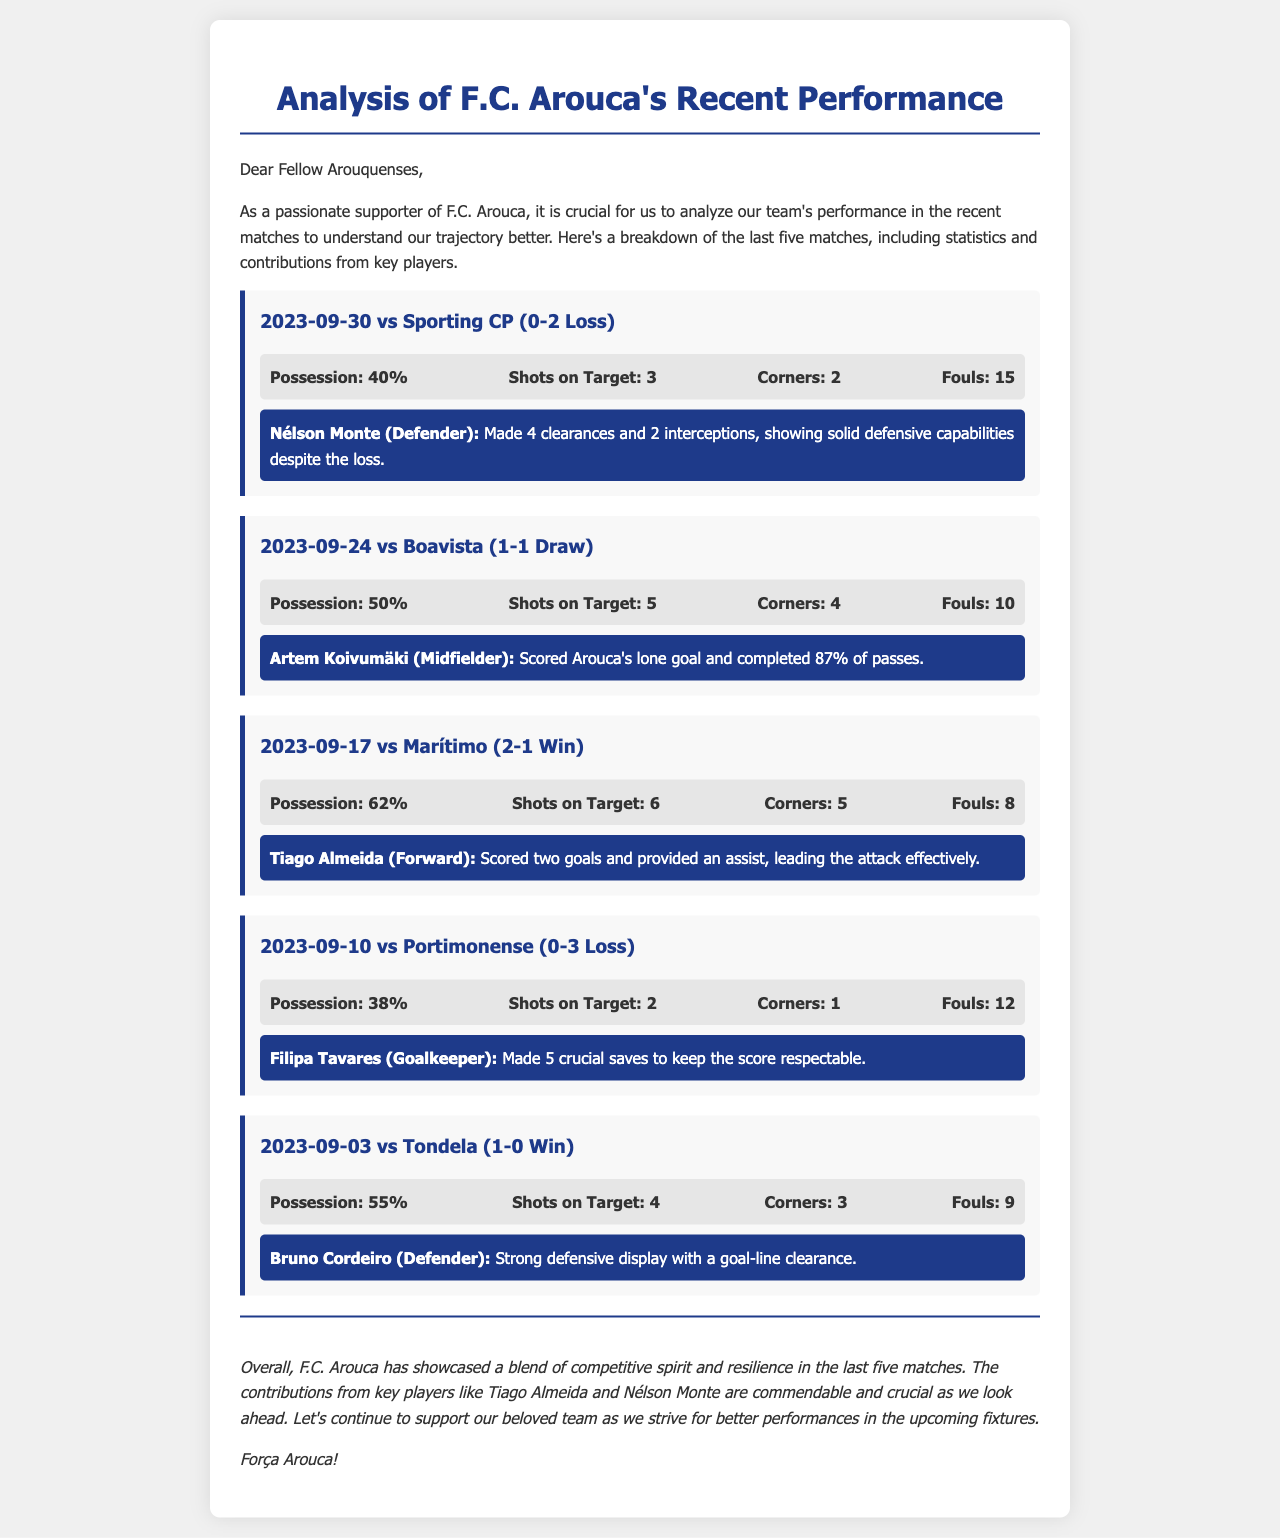What was F.C. Arouca's possession percentage against Sporting CP? The document states that F.C. Arouca had 40% possession in the match against Sporting CP.
Answer: 40% Who scored Arouca's lone goal in the match against Boavista? The document mentions that Artem Koivumäki scored Arouca's only goal in the match against Boavista.
Answer: Artem Koivumäki How many corners did F.C. Arouca have in the match against Marítimo? According to the document, F.C. Arouca had 5 corners in the match against Marítimo.
Answer: 5 What was the outcome of the match on 2023-09-03 against Tondela? The document indicates that F.C. Arouca won the match against Tondela.
Answer: Win Which player made 5 crucial saves against Portimonense? The document states that Filipa Tavares made 5 crucial saves during the match against Portimonense.
Answer: Filipa Tavares What is highlighted about Tiago Almeida's performance in the match against Marítimo? The document highlights that Tiago Almeida scored two goals and provided an assist in the match against Marítimo.
Answer: Scored two goals and provided an assist In how many matches did F.C. Arouca score goals in the last five games analyzed? The document notes that F.C. Arouca scored in three matches: against Marítimo, Tondela, and Boavista.
Answer: Three matches What is the overall theme of the conclusion in the analysis? The document concludes with a theme of competitive spirit and resilience shown by F.C. Arouca in recent matches.
Answer: Competitive spirit and resilience 